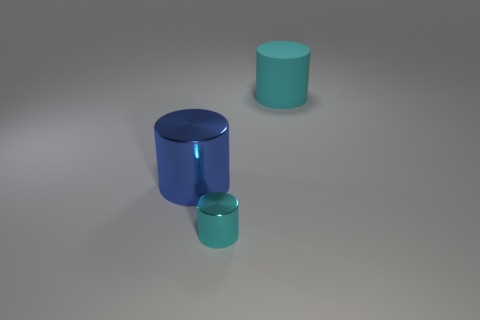There is another cylinder that is the same color as the matte cylinder; what is its material?
Your answer should be very brief. Metal. Is there anything else that has the same size as the cyan shiny object?
Your answer should be compact. No. There is a cyan thing in front of the big object that is in front of the big thing right of the large shiny thing; what is its material?
Your response must be concise. Metal. The cyan cylinder that is behind the thing that is in front of the blue metal cylinder is made of what material?
Offer a terse response. Rubber. Are there fewer tiny cylinders that are to the right of the rubber object than blue objects?
Make the answer very short. Yes. Does the blue cylinder have the same size as the cylinder to the right of the tiny cyan cylinder?
Give a very brief answer. Yes. Is there a block made of the same material as the tiny cyan thing?
Give a very brief answer. No. How many cylinders are blue metal things or large objects?
Your answer should be compact. 2. Are there any cylinders in front of the cyan object that is behind the big blue shiny thing?
Your answer should be compact. Yes. Are there fewer big matte things than big gray matte spheres?
Offer a terse response. No. 